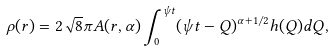<formula> <loc_0><loc_0><loc_500><loc_500>\rho ( r ) = 2 \sqrt { 8 } \pi A ( r , \alpha ) \int _ { 0 } ^ { \psi t } ( \psi t - Q ) ^ { \alpha + 1 / 2 } h ( Q ) d Q ,</formula> 